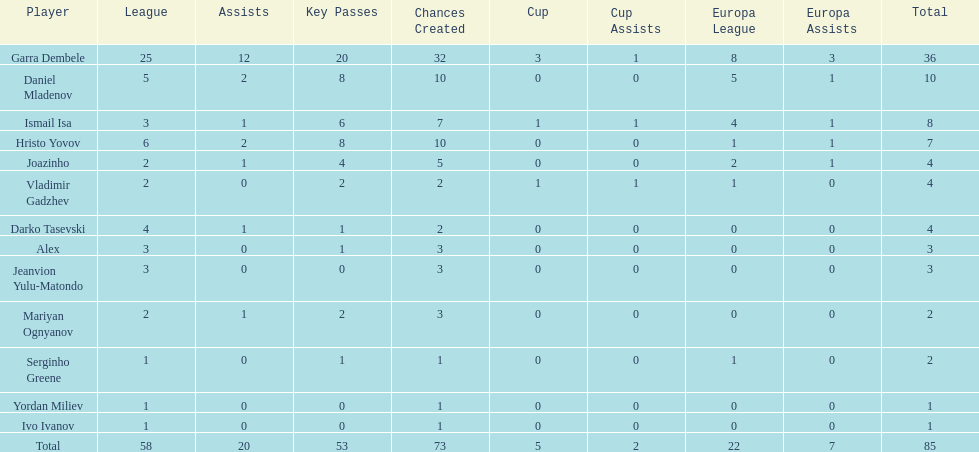Who had the most goal scores? Garra Dembele. 